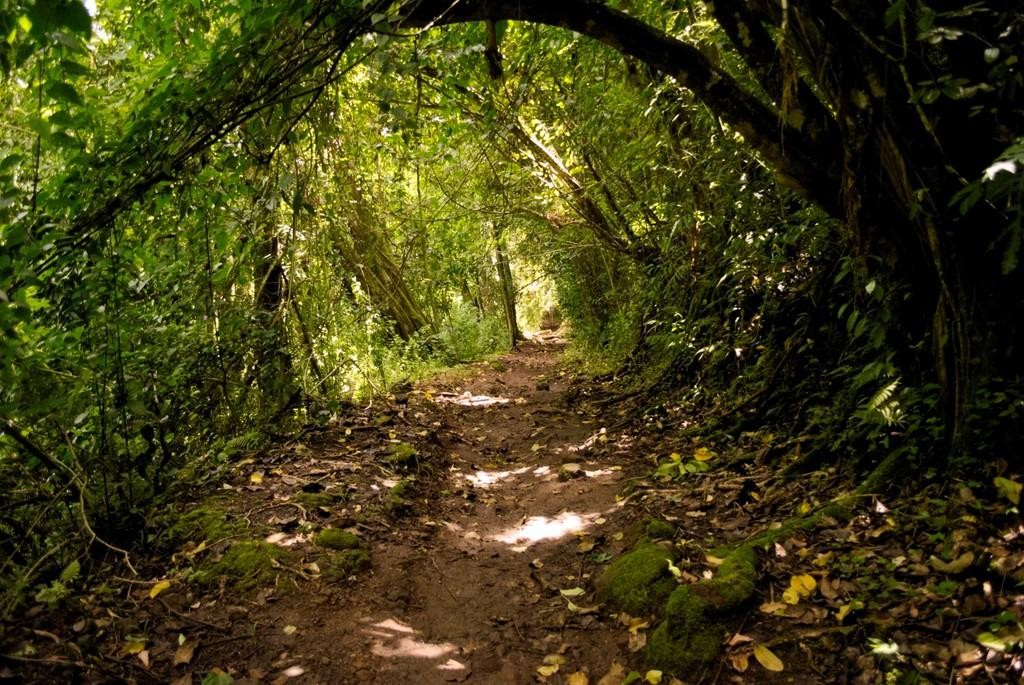What type of vegetation is present in the image? There is grass in the image. What type of pathway is visible in the image? There is a road in the image. What other natural elements can be seen in the image? There are trees in the image. What time of day might the image have been taken? The image was likely taken during the day, as there is sufficient light to see the details. Where might the image have been taken? The image may have been taken in a forest, given the presence of grass, trees, and a road. What color is the partner's sweater in the image? There is no partner or sweater present in the image. Can you describe the volleyball game happening in the background of the image? There is no volleyball game present in the image; it features grass, a road, and trees. 